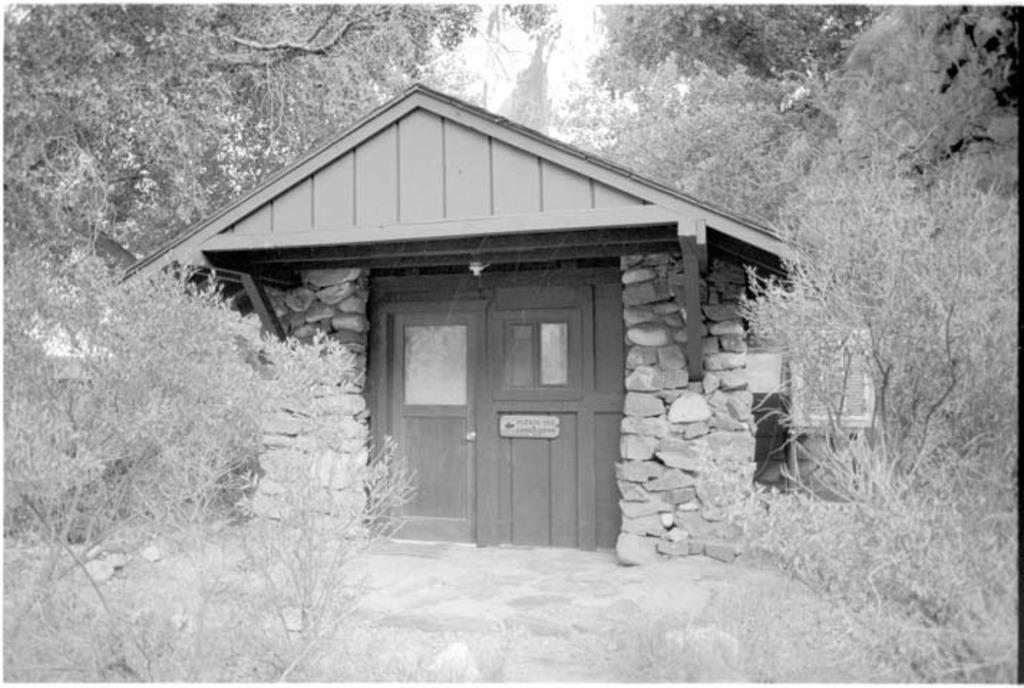Describe this image in one or two sentences. In the given image i can see a shack,plants and trees. 